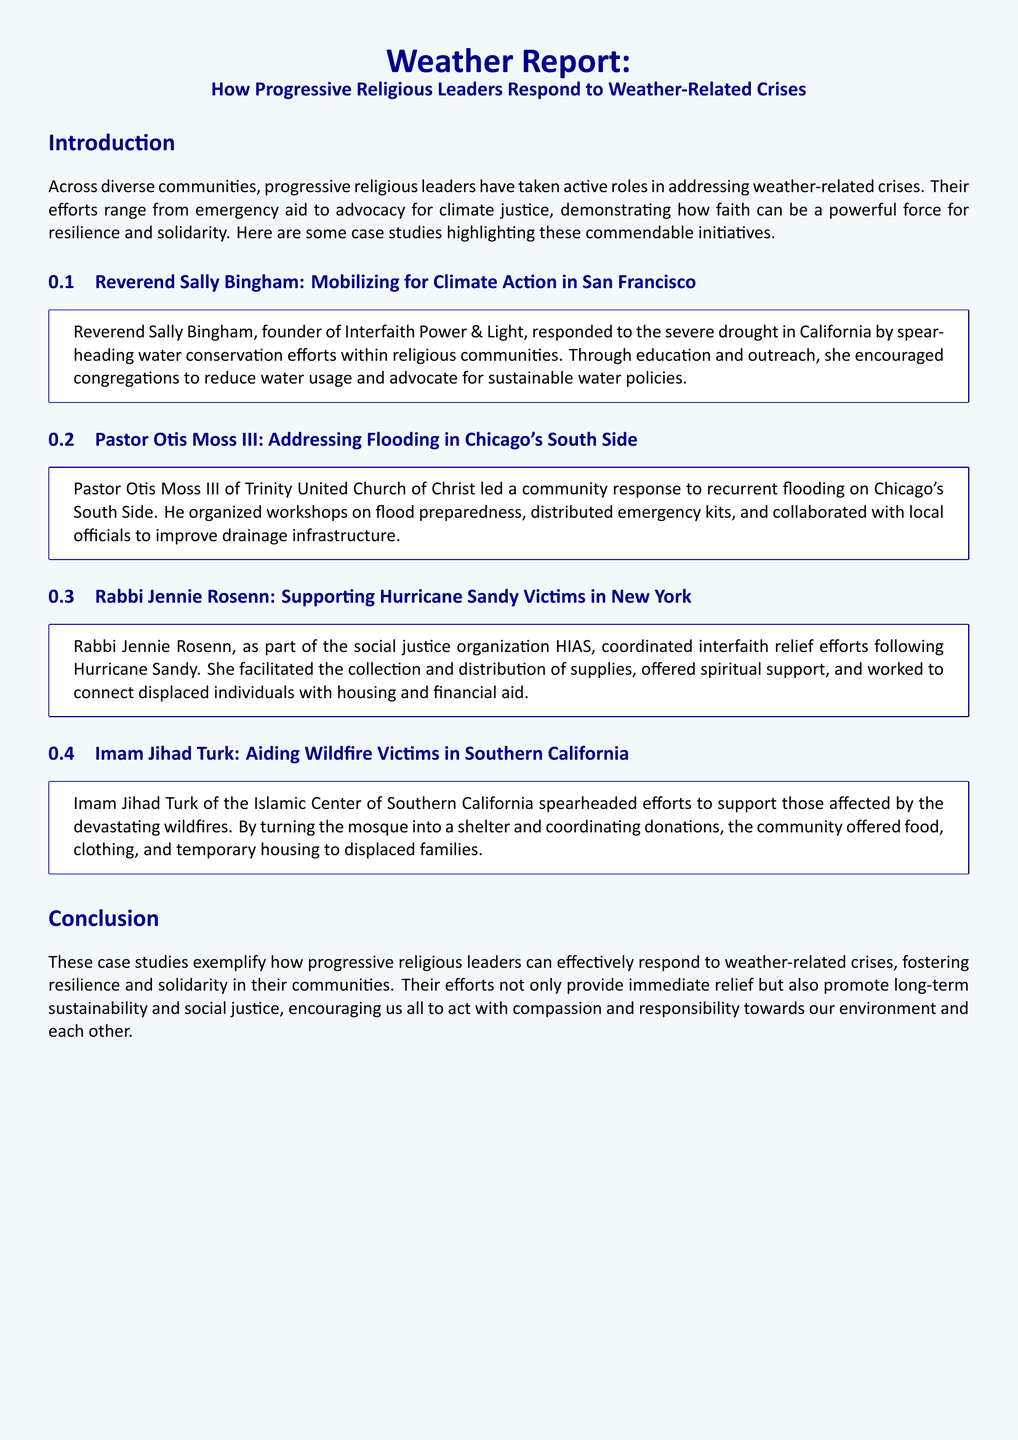What is the name of the organization founded by Reverend Sally Bingham? Reverend Sally Bingham founded Interfaith Power & Light, as mentioned in her case study.
Answer: Interfaith Power & Light What weather-related crisis did Pastor Otis Moss III respond to? Pastor Otis Moss III responded to recurrent flooding on Chicago's South Side, as stated in the document.
Answer: Flooding Which hurricane did Rabbi Jennie Rosenn support victims of? The document specifies that Rabbi Jennie Rosenn coordinated relief efforts following Hurricane Sandy.
Answer: Hurricane Sandy What role did Imam Jihad Turk have during the wildfires? Imam Jihad Turk of the Islamic Center of Southern California spearheaded efforts to support those affected, as noted in his case study.
Answer: Spearheaded efforts How did Reverend Sally Bingham promote water conservation? Reverend Sally Bingham encouraged congregations to reduce water usage and advocate for sustainable water policies, according to her case study.
Answer: Education and outreach Which type of support did Rabbi Jennie Rosenn offer to victims? Rabbi Jennie Rosenn offered spiritual support to Hurricane Sandy victims, as highlighted in her case study.
Answer: Spiritual support What was the purpose of the workshops organized by Pastor Otis Moss III? The workshops organized by Pastor Otis Moss III were on flood preparedness, as outlined in the document.
Answer: Flood preparedness What is the main theme of the case studies presented? The main theme is how progressive religious leaders respond to weather-related crises, as introduced in the document.
Answer: Progressive religious responses How many case studies are included in the document? The document presents a total of four case studies, as listed within its sections.
Answer: Four 